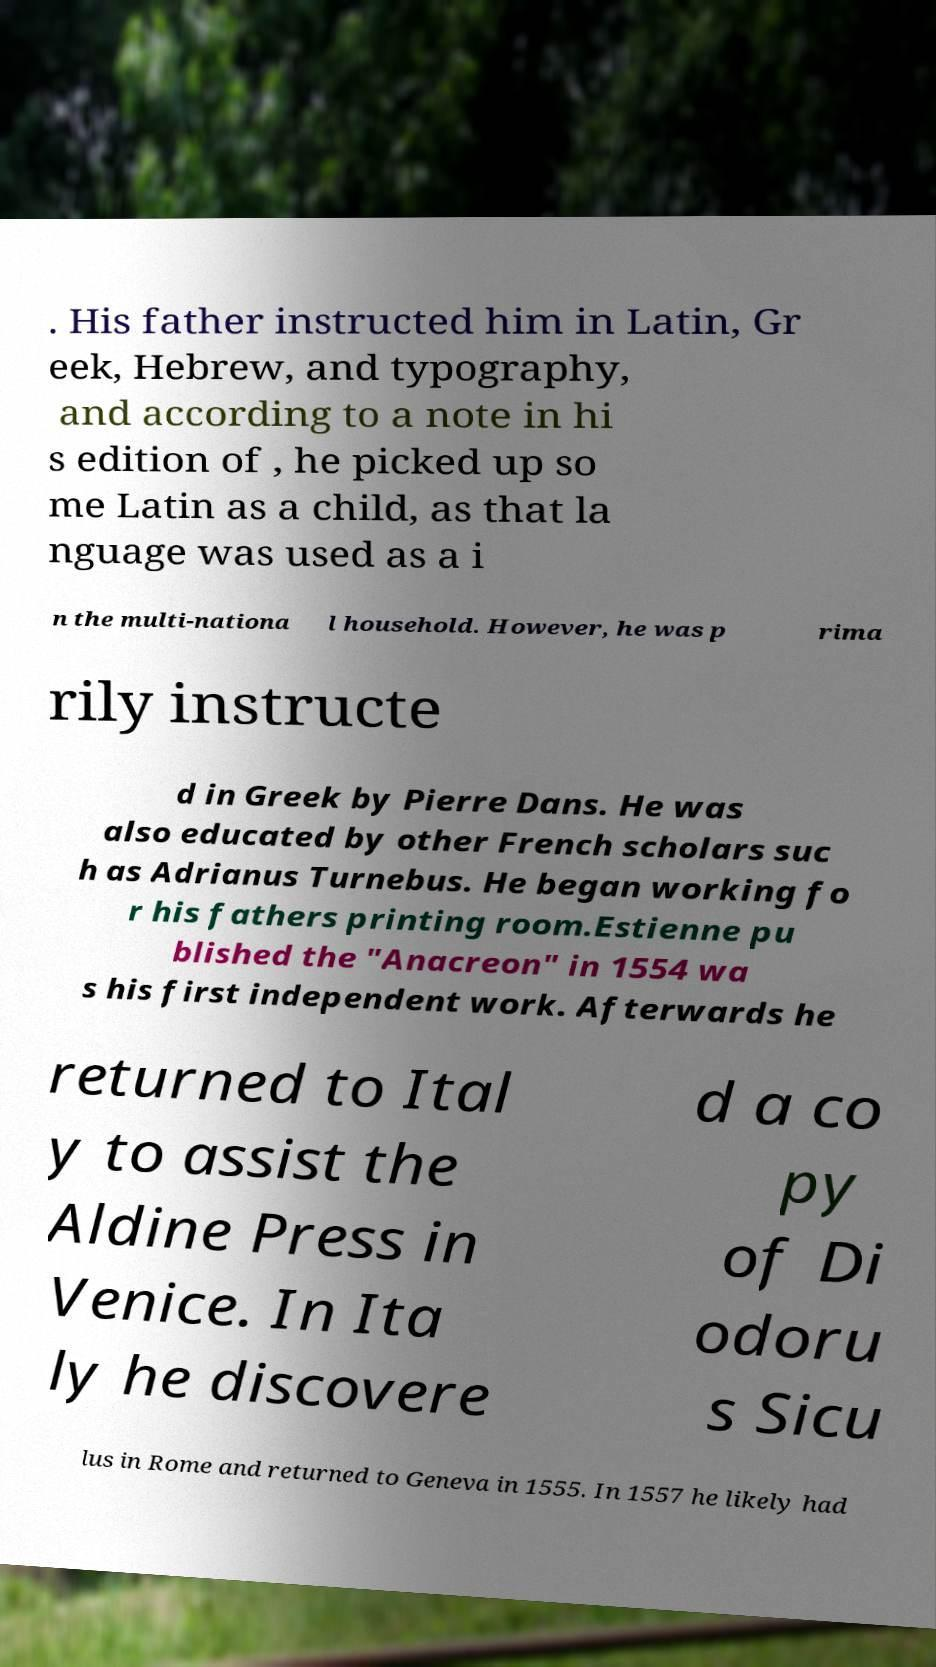What messages or text are displayed in this image? I need them in a readable, typed format. . His father instructed him in Latin, Gr eek, Hebrew, and typography, and according to a note in hi s edition of , he picked up so me Latin as a child, as that la nguage was used as a i n the multi-nationa l household. However, he was p rima rily instructe d in Greek by Pierre Dans. He was also educated by other French scholars suc h as Adrianus Turnebus. He began working fo r his fathers printing room.Estienne pu blished the "Anacreon" in 1554 wa s his first independent work. Afterwards he returned to Ital y to assist the Aldine Press in Venice. In Ita ly he discovere d a co py of Di odoru s Sicu lus in Rome and returned to Geneva in 1555. In 1557 he likely had 